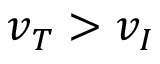Convert formula to latex. <formula><loc_0><loc_0><loc_500><loc_500>v _ { T } > v _ { I }</formula> 